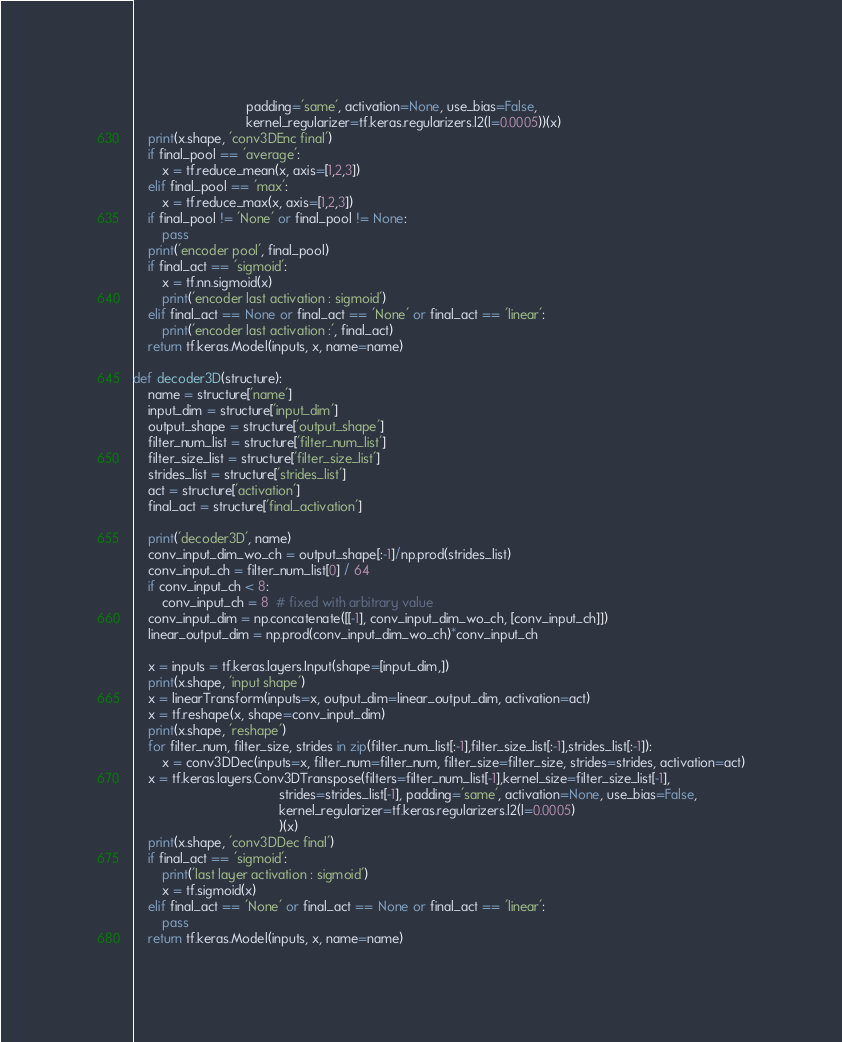<code> <loc_0><loc_0><loc_500><loc_500><_Python_>                               padding='same', activation=None, use_bias=False,
                               kernel_regularizer=tf.keras.regularizers.l2(l=0.0005))(x)
    print(x.shape, 'conv3DEnc final')
    if final_pool == 'average':
        x = tf.reduce_mean(x, axis=[1,2,3])
    elif final_pool == 'max':
        x = tf.reduce_max(x, axis=[1,2,3])
    if final_pool != 'None' or final_pool != None:
        pass
    print('encoder pool', final_pool)
    if final_act == 'sigmoid':
        x = tf.nn.sigmoid(x)
        print('encoder last activation : sigmoid')
    elif final_act == None or final_act == 'None' or final_act == 'linear':
        print('encoder last activation :', final_act)
    return tf.keras.Model(inputs, x, name=name)

def decoder3D(structure):
    name = structure['name']
    input_dim = structure['input_dim']
    output_shape = structure['output_shape']
    filter_num_list = structure['filter_num_list']
    filter_size_list = structure['filter_size_list']
    strides_list = structure['strides_list']
    act = structure['activation']
    final_act = structure['final_activation']

    print('decoder3D', name)
    conv_input_dim_wo_ch = output_shape[:-1]/np.prod(strides_list)
    conv_input_ch = filter_num_list[0] / 64
    if conv_input_ch < 8:
        conv_input_ch = 8  # fixed with arbitrary value
    conv_input_dim = np.concatenate([[-1], conv_input_dim_wo_ch, [conv_input_ch]])
    linear_output_dim = np.prod(conv_input_dim_wo_ch)*conv_input_ch

    x = inputs = tf.keras.layers.Input(shape=[input_dim,])
    print(x.shape, 'input shape')
    x = linearTransform(inputs=x, output_dim=linear_output_dim, activation=act)
    x = tf.reshape(x, shape=conv_input_dim)
    print(x.shape, 'reshape')
    for filter_num, filter_size, strides in zip(filter_num_list[:-1],filter_size_list[:-1],strides_list[:-1]):
        x = conv3DDec(inputs=x, filter_num=filter_num, filter_size=filter_size, strides=strides, activation=act)
    x = tf.keras.layers.Conv3DTranspose(filters=filter_num_list[-1],kernel_size=filter_size_list[-1],
                                        strides=strides_list[-1], padding='same', activation=None, use_bias=False,
                                        kernel_regularizer=tf.keras.regularizers.l2(l=0.0005)
                                        )(x)
    print(x.shape, 'conv3DDec final')
    if final_act == 'sigmoid':
        print('last layer activation : sigmoid')
        x = tf.sigmoid(x)
    elif final_act == 'None' or final_act == None or final_act == 'linear':
        pass
    return tf.keras.Model(inputs, x, name=name)






</code> 